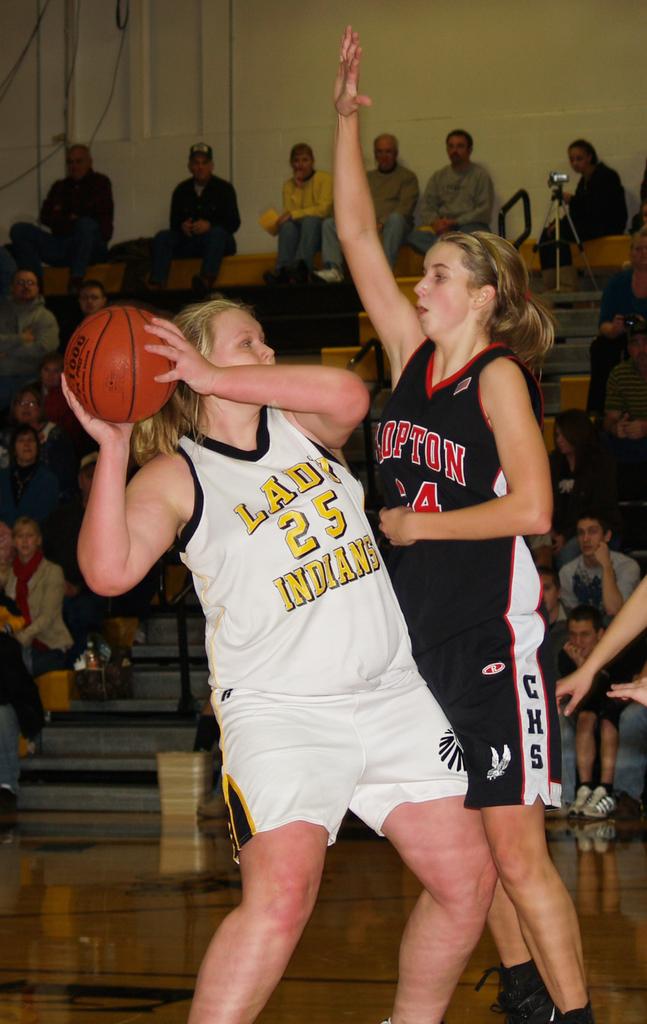What is the lady in whites team number?
Ensure brevity in your answer.  25. 